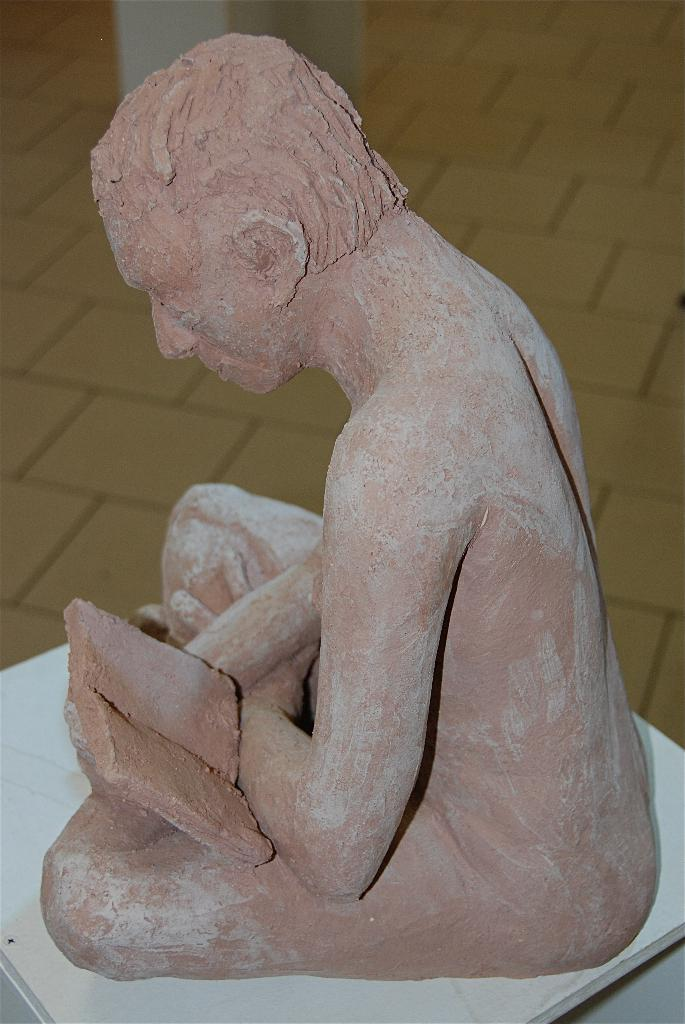What is the main subject in the foreground of the image? There is a sculpture in the foreground of the image. Where is the sculpture located? The sculpture appears to be on a table. What can be seen in the background of the image? There is a pillar in the background of the image. What surface is visible beneath the sculpture and table? There is a floor visible in the image. What type of meal is being prepared on the table in the image? There is no meal being prepared in the image; it features a sculpture on a table. What color is the man's shirt in the image? There is no man present in the image, so it is not possible to determine the color of his shirt. 